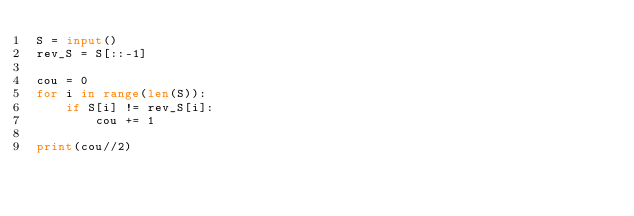Convert code to text. <code><loc_0><loc_0><loc_500><loc_500><_Python_>S = input()
rev_S = S[::-1]

cou = 0
for i in range(len(S)):
    if S[i] != rev_S[i]:
        cou += 1

print(cou//2)</code> 